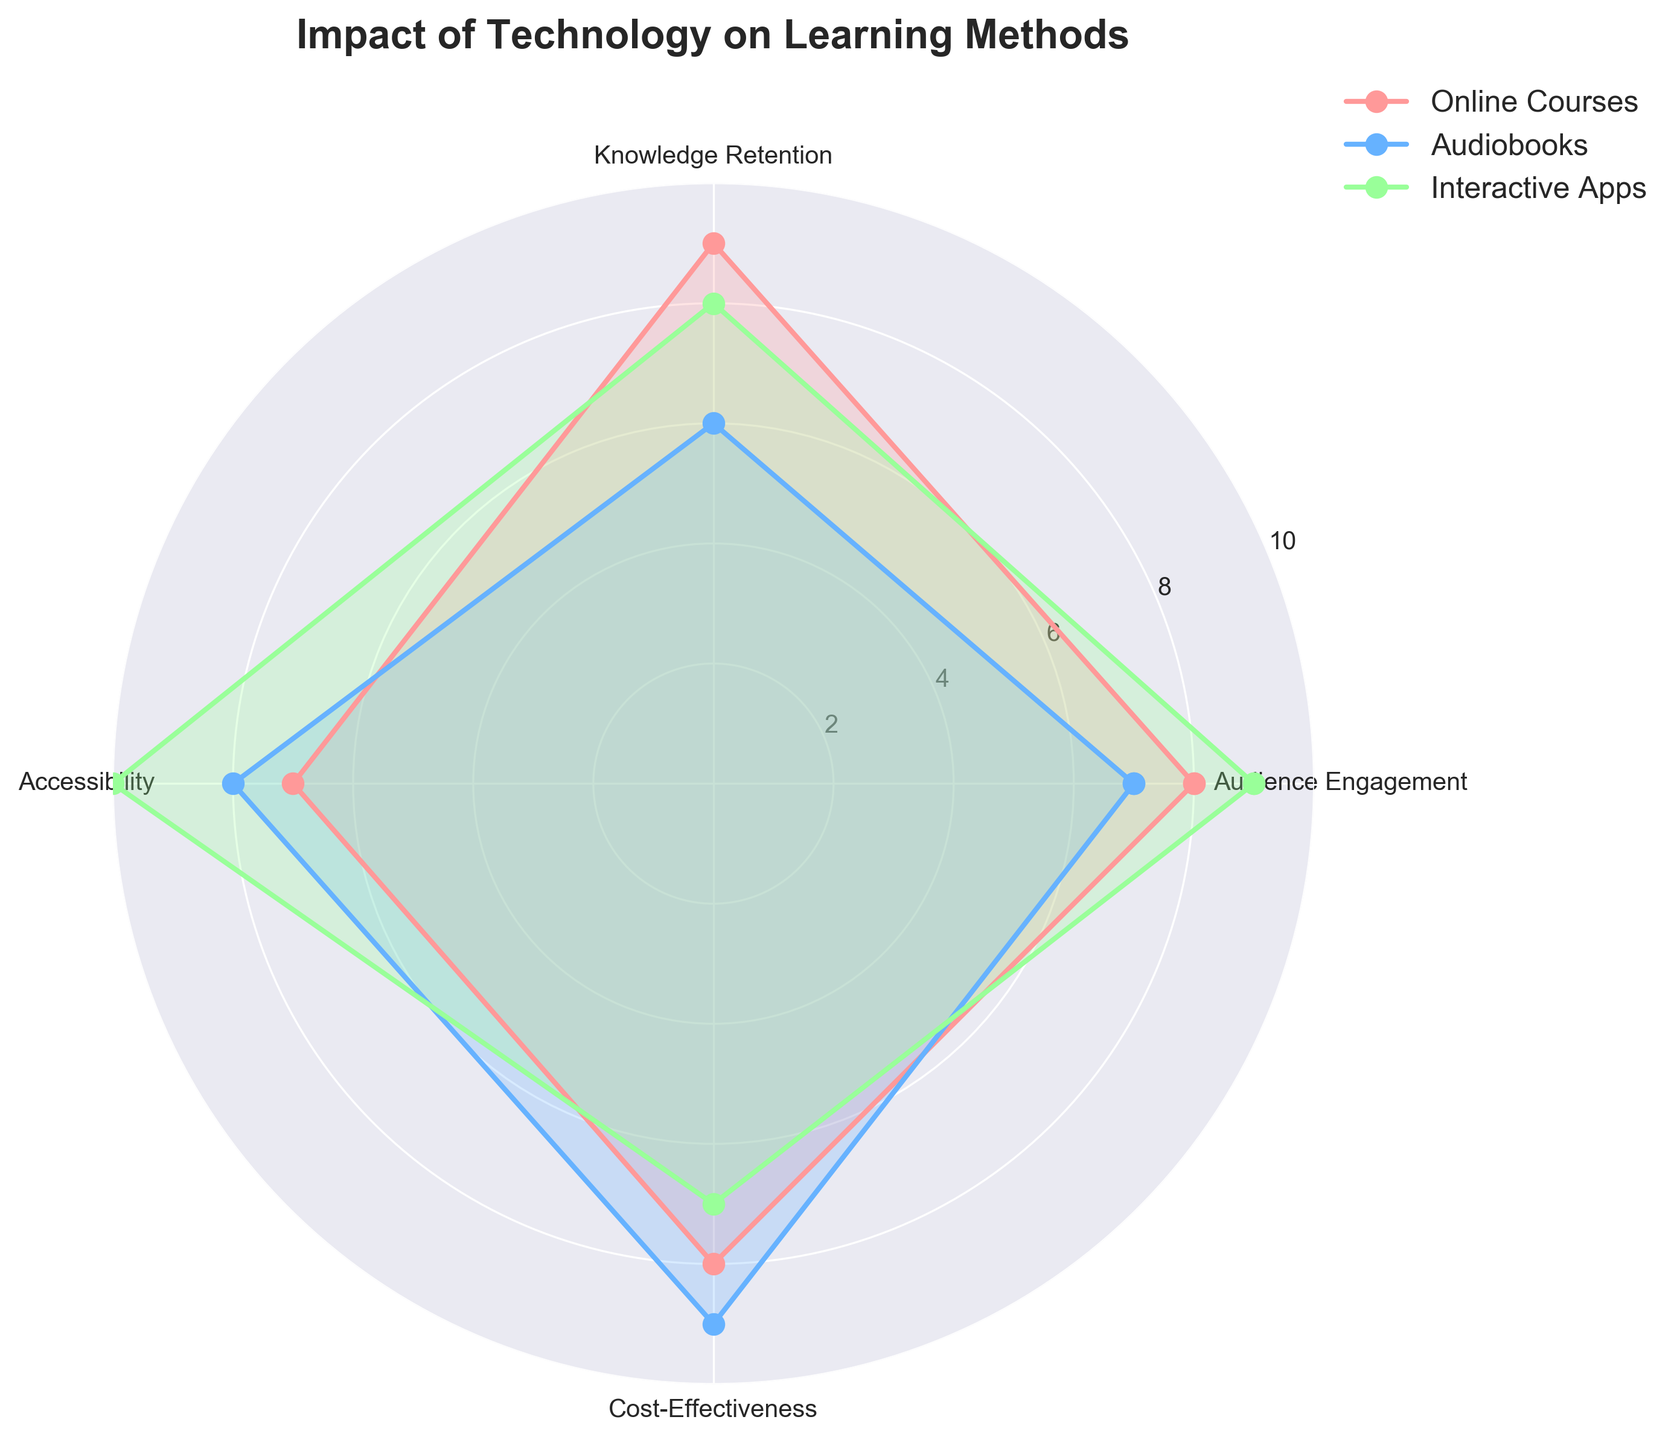What is the title of the radar chart? The title of the chart is usually displayed at the top of the figure. It can be read directly without any calculations or comparisons.
Answer: Impact of Technology on Learning Methods How many learning methods are compared in the chart? The radar chart compares different groups, each representing a learning method. By observing the legend or the lines in the chart, one can identify the number of groups.
Answer: 3 Which learning method has the highest value for Audience Engagement? By looking at the values around the Audience Engagement axis and the extending lines for each method, you can see which line reaches the highest value.
Answer: Interactive Apps What learning method has the lowest Knowledge Retention value? By observing the axis for Knowledge Retention and comparing the lines of each method, the one with the lowest position is identified.
Answer: Audiobooks What's the average Accessibility value across all learning methods? Sum the Accessibility values for all methods and then divide by the number of methods. The values are 7 (Online Courses), 8 (Audiobooks), and 10 (Interactive Apps). (7 + 8 + 10) / 3 = 25 / 3
Answer: 8.33 Which learning method scores better in Cost-Effectiveness compared to Online Courses? Compare the Cost-Effectiveness values of the learning methods with the value of Online Courses (8). Audiobooks are higher at 9, while Interactive Apps are lower at 7.
Answer: Audiobooks What is the sum of Knowledge Retention and Cost-Effectiveness for Interactive Apps? Add the Knowledge Retention value and the Cost-Effectiveness value for Interactive Apps. For Interactive Apps, Knowledge Retention is 8 and Cost-Effectiveness is 7. (8 + 7)
Answer: 15 Which learning method has the most balanced scores across all categories? By looking at the radar chart, observe which learning method has values that are close to each other in all categories, indicating balance.
Answer: Online Courses Compare the total score of Online Courses and Audiobooks by summing up their values for all metrics. Which one is higher? Sum the scores for each method across all metrics: Online Courses (8 + 9 + 7 + 8 = 32) and Audiobooks (7 + 6 + 8 + 9 = 30). Compare the sums.
Answer: Online Courses How many categories are present in the radar chart? Count the number of axes radiating from the center of the radar chart, each representing a category.
Answer: 4 